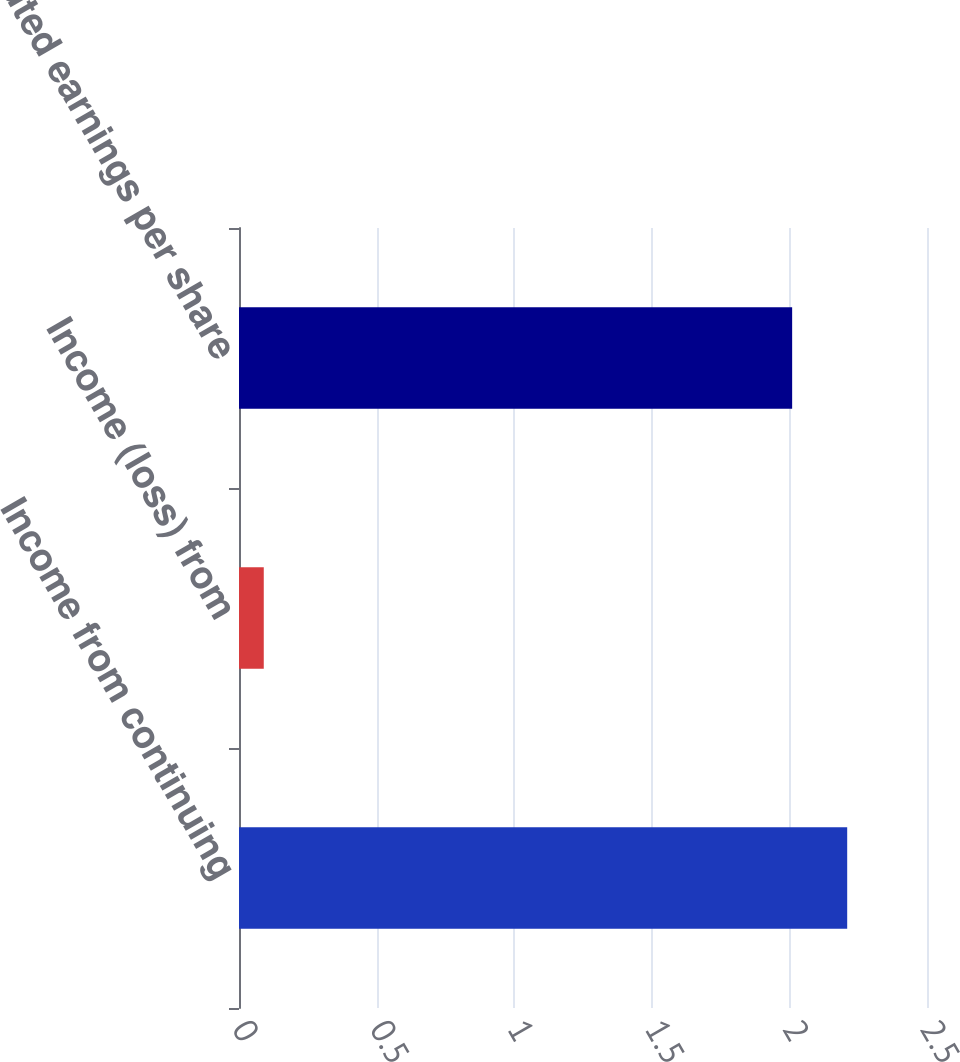Convert chart to OTSL. <chart><loc_0><loc_0><loc_500><loc_500><bar_chart><fcel>Income from continuing<fcel>Income (loss) from<fcel>Diluted earnings per share<nl><fcel>2.21<fcel>0.09<fcel>2.01<nl></chart> 